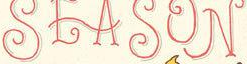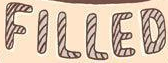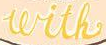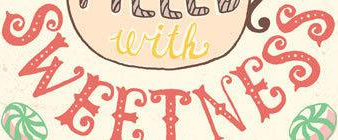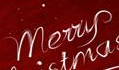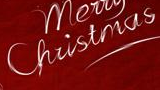What words are shown in these images in order, separated by a semicolon? SEASON; FILLED; with; SWEETNESS; Merry; Christmas 